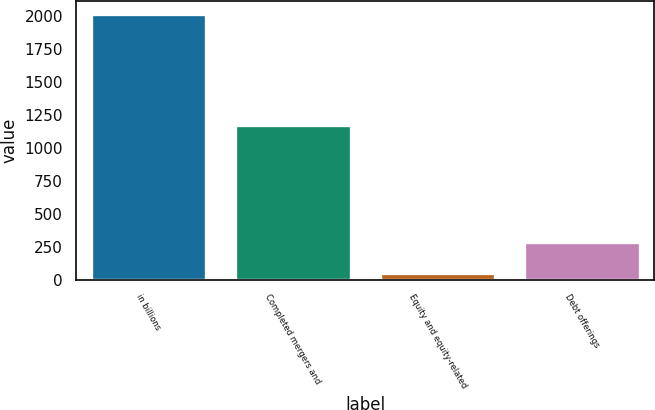Convert chart. <chart><loc_0><loc_0><loc_500><loc_500><bar_chart><fcel>in billions<fcel>Completed mergers and<fcel>Equity and equity-related<fcel>Debt offerings<nl><fcel>2016<fcel>1170<fcel>47<fcel>282<nl></chart> 